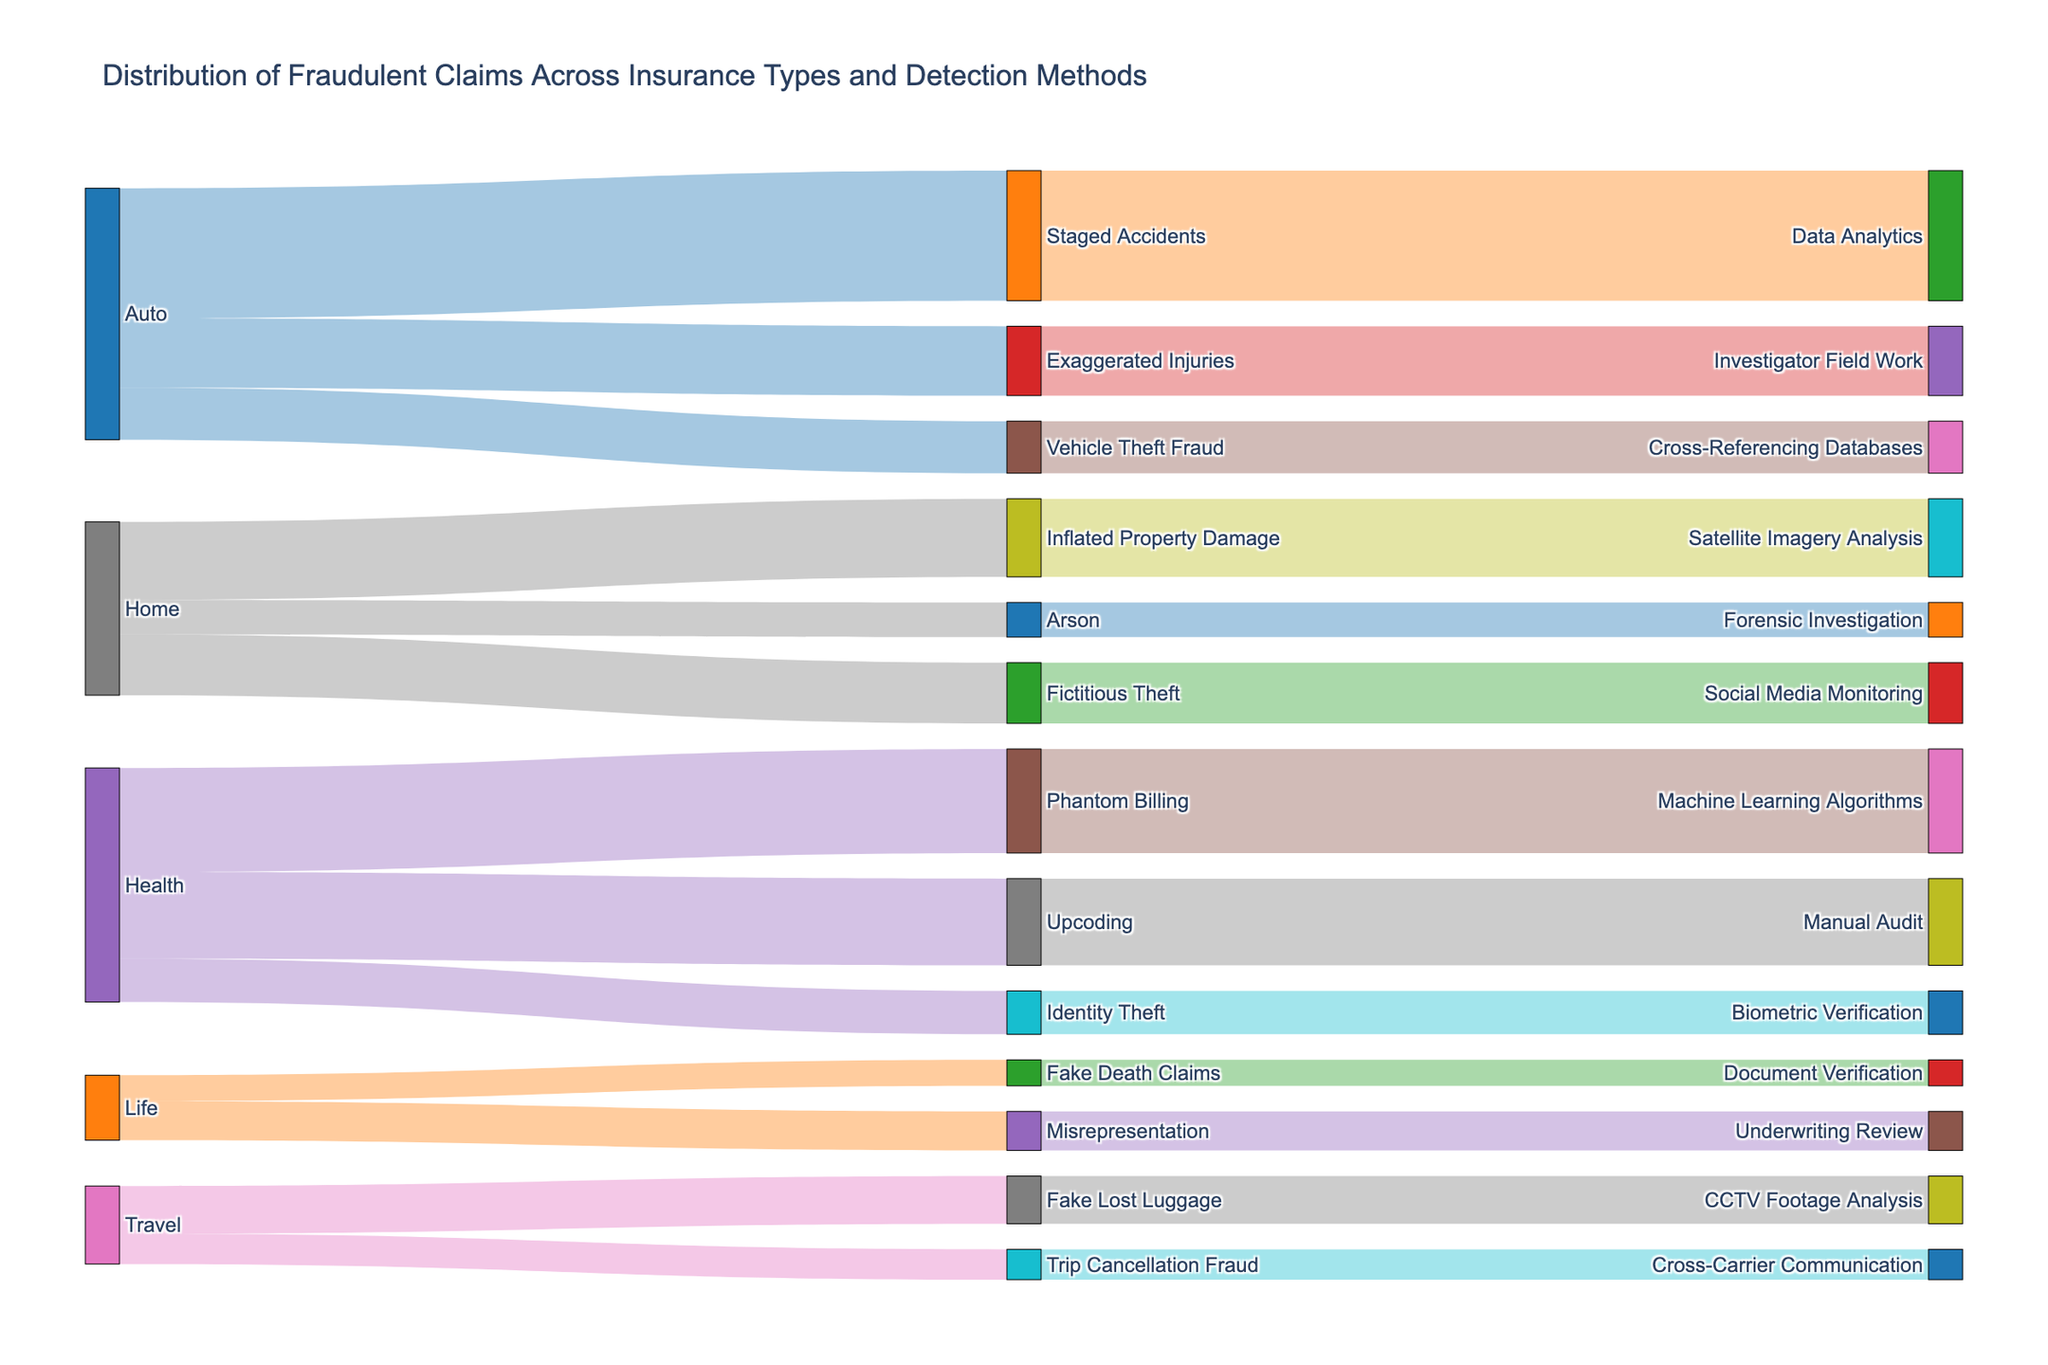What is the title of the figure? The title is typically placed at the top of the figure, summarizing the main topic of the visualization. Reading the top of the figure will provide you with this information.
Answer: Distribution of Fraudulent Claims Across Insurance Types and Detection Methods Which insurance type has the highest number of claims for a single fraud type? Identify the largest value among the claims linked to each insurance type. Look for the highest bar or flow in the sankey diagram sections connected to specific insurance types and their respective fraud types.
Answer: Auto (Staged Accidents with 150 claims) What detection method is most frequently used for Auto insurance fraud claims? Follow the flows from the "Auto" insurance type to the linked "Fraud Types," and then to the "Detection Methods." Identify which detection method has the most claims linked to it.
Answer: Data Analytics How many claims are identified through 'Social Media Monitoring' for Home insurance fraud? Locate the 'Home' insurance type and trace its claims through various 'Fraud Types' to see which ones lead to the 'Social Media Monitoring' detection method. Summing the values along this path provides the total claims.
Answer: 70 Compare the number of claims for 'Document Verification' in Life insurance fraud to 'Cross-Carrier Communication' in Travel insurance fraud. Which has more claims? Locate both 'Life' and 'Travel' insurance types. Trace their claims to the 'Document Verification' and 'Cross-Carrier Communication' detection methods respectively. Compare the values to determine which one is greater.
Answer: Document Verification (30 claims) has more than Cross-Carrier Communication (35 claims) What is the combined number of claims for 'Biometric Verification' and 'Forensic Investigation' detection methods? Locate the claims linked to 'Biometric Verification' and 'Forensic Investigation'. Summing the values reported for these detection methods will provide the total.
Answer: 50 (Biometric Verification) + 40 (Forensic Investigation) = 90 Which fraud type in Health insurance has the least number of claims? Identify the fraud types under Health insurance and compare the number of claims linked to each to find the one with the least number.
Answer: Identity Theft (50 claims) Calculate the total number of claims for 'Underwriting Review' and 'Manual Audit' detection methods combined. Find the number of claims associated with both 'Underwriting Review' and 'Manual Audit' detection methods and add them together.
Answer: 45 (Underwriting Review) + 100 (Manual Audit) = 145 Is the number of claims for 'CCTV Footage Analysis' in Travel insurance fraud higher or lower than those for 'Machine Learning Algorithms' in Health insurance fraud? Compare the flows leading to 'CCTV Footage Analysis' from Travel insurance and 'Machine Learning Algorithms' from Health insurance. Check which one has a higher value.
Answer: Lower (CCTV Footage Analysis: 55 claims, Machine Learning Algorithms: 120 claims) How many total claims are associated with 'Auto' insurance type across all fraud types? Summing the claims for all fraud types linked to 'Auto' insurance will provide the total number of claims for Auto.
Answer: 150 (Staged Accidents) + 80 (Exaggerated Injuries) + 60 (Vehicle Theft Fraud) = 290 